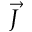Convert formula to latex. <formula><loc_0><loc_0><loc_500><loc_500>\vec { J }</formula> 